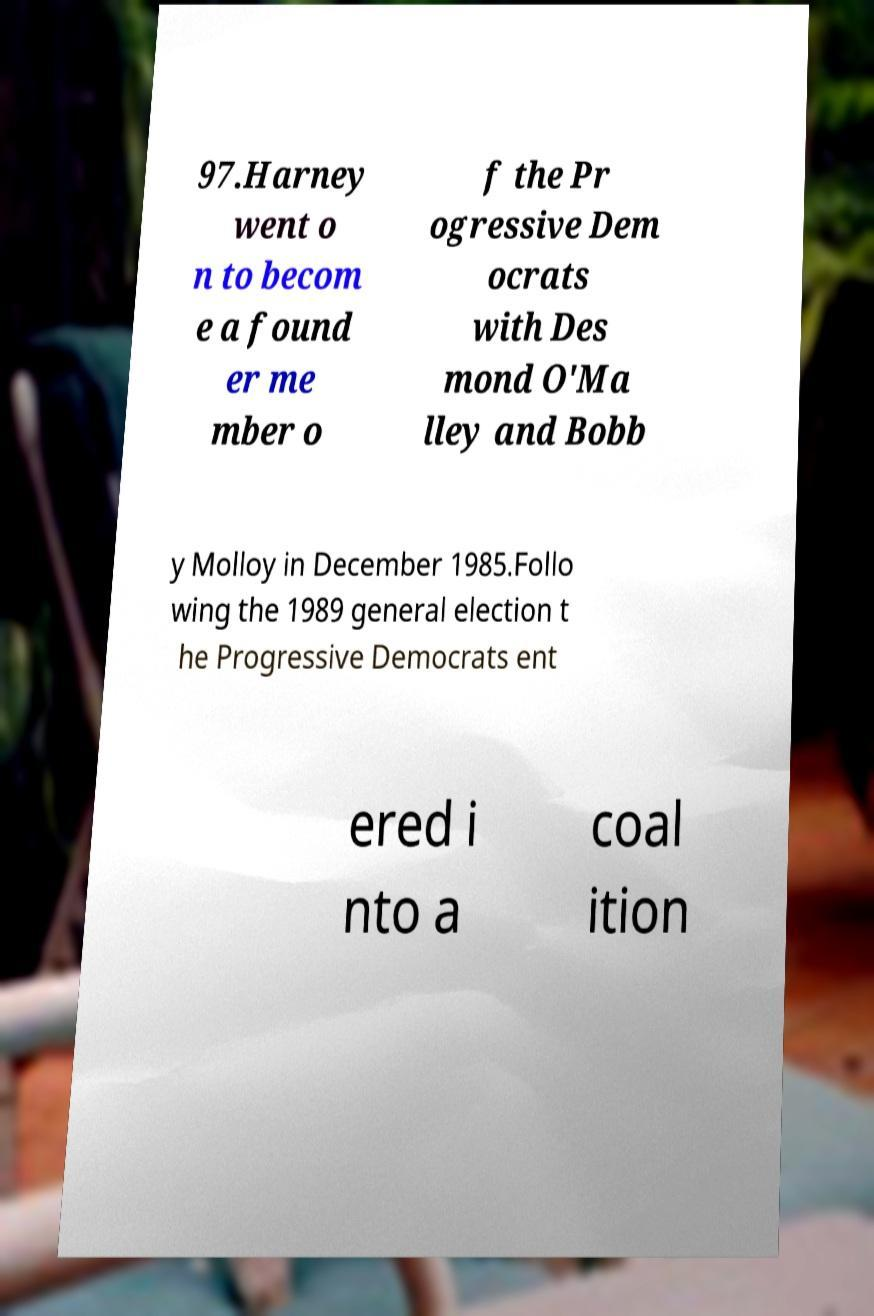I need the written content from this picture converted into text. Can you do that? 97.Harney went o n to becom e a found er me mber o f the Pr ogressive Dem ocrats with Des mond O'Ma lley and Bobb y Molloy in December 1985.Follo wing the 1989 general election t he Progressive Democrats ent ered i nto a coal ition 